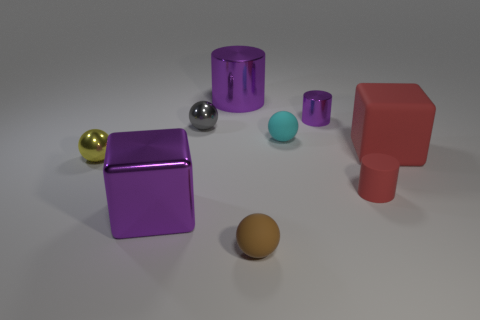Subtract all blue balls. How many purple cylinders are left? 2 Add 1 small matte spheres. How many objects exist? 10 Subtract all gray spheres. How many spheres are left? 3 Subtract all small cyan rubber balls. How many balls are left? 3 Subtract 1 balls. How many balls are left? 3 Subtract all blue balls. Subtract all yellow blocks. How many balls are left? 4 Subtract all balls. How many objects are left? 5 Add 9 big rubber things. How many big rubber things exist? 10 Subtract 0 blue balls. How many objects are left? 9 Subtract all small purple shiny cubes. Subtract all balls. How many objects are left? 5 